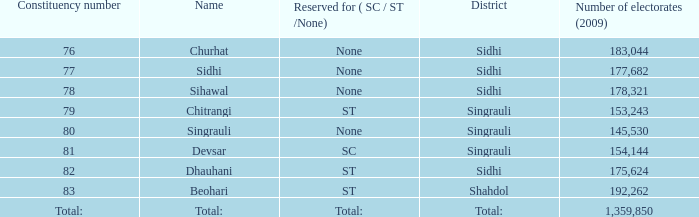What is the district with 79 constituency number? Singrauli. 